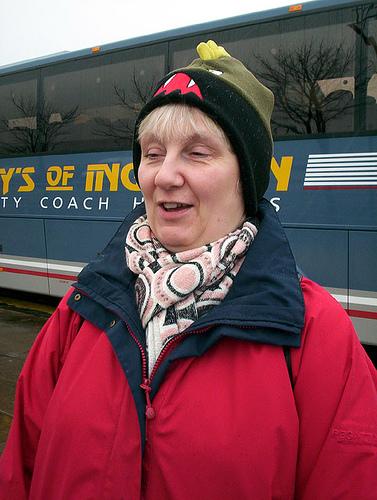What color is her coat?
Write a very short answer. Red. What color is the woman's hair?
Quick response, please. Blonde. What is behind the woman?
Write a very short answer. Bus. What sporting equipment is next to the lady?
Keep it brief. None. 